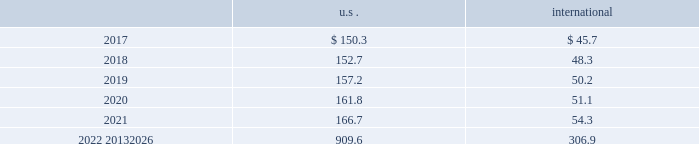Corporate and government bonds corporate and government bonds are classified as level 2 assets , as they are either valued at quoted market prices from observable pricing sources at the reporting date or valued based upon comparable securities with similar yields and credit ratings .
Real estate pooled funds real estate pooled funds are classified as level 3 assets , as they are carried at the estimated fair value of the underlying properties .
Estimated fair value is calculated utilizing a combination of key inputs , such as revenue and expense growth rates , terminal capitalization rates , and discount rates .
These key inputs are consistent with practices prevailing within the real estate investment management industry .
Other pooled funds other pooled funds classified as level 2 assets are valued at the nav of the shares held at year end , which is based on the fair value of the underlying investments .
Securities and interests classified as level 3 are carried at the estimated fair value .
The estimated fair value is based on the fair value of the underlying investment values , which includes estimated bids from brokers or other third-party vendor sources that utilize expected cash flow streams and other uncorroborated data including counterparty credit quality , default risk , discount rates , and the overall capital market liquidity .
Insurance contracts insurance contracts are classified as level 3 assets , as they are carried at contract value , which approximates the estimated fair value .
The estimated fair value is based on the fair value of the underlying investment of the insurance company .
Contributions and projected benefit payments pension contributions to funded plans and benefit payments for unfunded plans for fiscal year 2016 were $ 79.3 .
Contributions for funded plans resulted primarily from contractual and regulatory requirements .
Benefit payments to unfunded plans were due primarily to the timing of retirements and cost reduction actions .
We anticipate contributing $ 65 to $ 85 to the defined benefit pension plans in 2017 .
These contributions are anticipated to be driven primarily by contractual and regulatory requirements for funded plans and benefit payments for unfunded plans , which are dependent upon timing of retirements and actions to reorganize the business .
Projected benefit payments , which reflect expected future service , are as follows: .
These estimated benefit payments are based on assumptions about future events .
Actual benefit payments may vary significantly from these estimates .
Defined contribution plans we maintain a nonleveraged employee stock ownership plan ( esop ) which forms part of the air products and chemicals , inc .
Retirement savings plan ( rsp ) .
The esop was established in may of 2002 .
The balance of the rsp is a qualified defined contribution plan including a 401 ( k ) elective deferral component .
A substantial portion of u.s .
Employees are eligible and participate .
We treat dividends paid on esop shares as ordinary dividends .
Under existing tax law , we may deduct dividends which are paid with respect to shares held by the plan .
Shares of the company 2019s common stock in the esop totaled 3031534 as of 30 september 2016 .
Our contributions to the rsp include a company core contribution for certain eligible employees who do not receive their primary retirement benefit from the defined benefit pension plans , with the core contribution based .
Considering the year 2017 , what is the lowest projected benefit payment value? 
Rationale: it is the minimum value of the projected benefit payment observed in that year .
Computations: table_min(2017, none)
Answer: 45.7. 